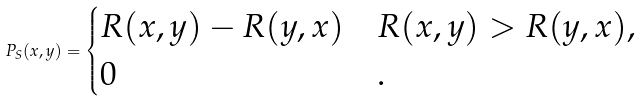<formula> <loc_0><loc_0><loc_500><loc_500>P _ { S } ( x , y ) = \begin{cases} R ( x , y ) - R ( y , x ) & R ( x , y ) > R ( y , x ) , \\ 0 & . \end{cases}</formula> 